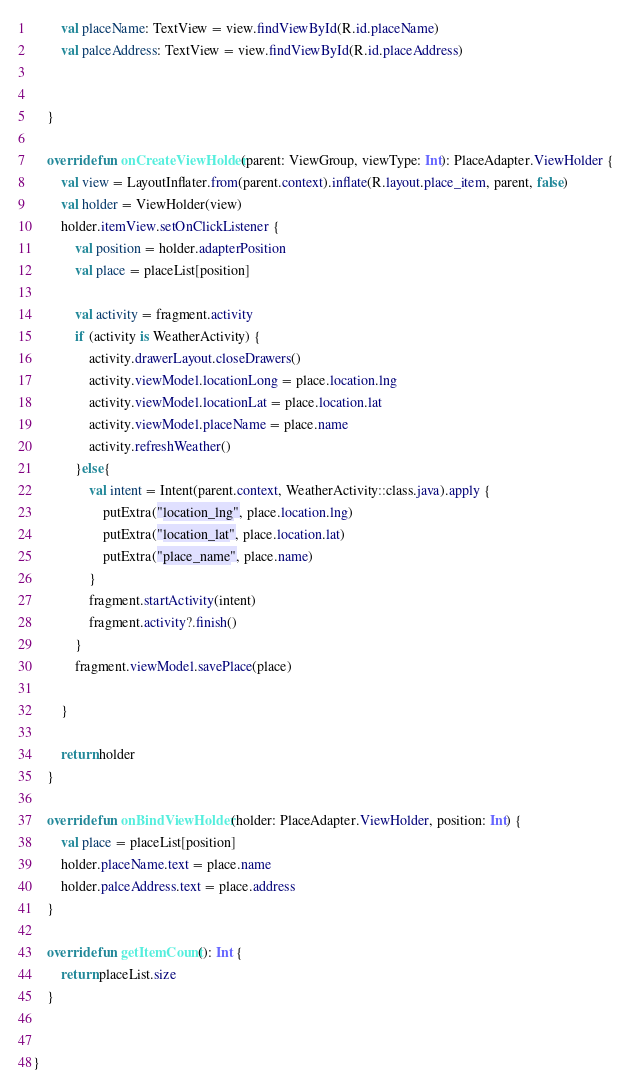<code> <loc_0><loc_0><loc_500><loc_500><_Kotlin_>        val placeName: TextView = view.findViewById(R.id.placeName)
        val palceAddress: TextView = view.findViewById(R.id.placeAddress)


    }

    override fun onCreateViewHolder(parent: ViewGroup, viewType: Int): PlaceAdapter.ViewHolder {
        val view = LayoutInflater.from(parent.context).inflate(R.layout.place_item, parent, false)
        val holder = ViewHolder(view)
        holder.itemView.setOnClickListener {
            val position = holder.adapterPosition
            val place = placeList[position]

            val activity = fragment.activity
            if (activity is WeatherActivity) {
                activity.drawerLayout.closeDrawers()
                activity.viewModel.locationLong = place.location.lng
                activity.viewModel.locationLat = place.location.lat
                activity.viewModel.placeName = place.name
                activity.refreshWeather()
            }else{
                val intent = Intent(parent.context, WeatherActivity::class.java).apply {
                    putExtra("location_lng", place.location.lng)
                    putExtra("location_lat", place.location.lat)
                    putExtra("place_name", place.name)
                }
                fragment.startActivity(intent)
                fragment.activity?.finish()
            }
            fragment.viewModel.savePlace(place)

        }

        return holder
    }

    override fun onBindViewHolder(holder: PlaceAdapter.ViewHolder, position: Int) {
        val place = placeList[position]
        holder.placeName.text = place.name
        holder.palceAddress.text = place.address
    }

    override fun getItemCount(): Int {
        return placeList.size
    }


}</code> 